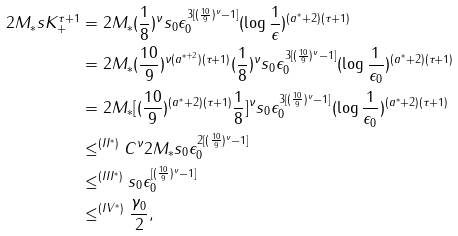Convert formula to latex. <formula><loc_0><loc_0><loc_500><loc_500>2 M _ { \ast } s K _ { + } ^ { \tau + 1 } & = 2 M _ { \ast } ( \frac { 1 } { 8 } ) ^ { \nu } s _ { 0 } \epsilon _ { 0 } ^ { 3 [ ( \frac { 1 0 } { 9 } ) ^ { \nu } - 1 ] } ( \log \frac { 1 } { \epsilon } ) ^ { ( a ^ { \ast } + 2 ) ( \tau + 1 ) } \\ & = 2 M _ { \ast } ( \frac { 1 0 } { 9 } ) ^ { \nu ( a ^ { \ast + 2 } ) ( \tau + 1 ) } ( \frac { 1 } { 8 } ) ^ { \nu } s _ { 0 } \epsilon _ { 0 } ^ { 3 [ ( \frac { 1 0 } { 9 } ) ^ { \nu } - 1 ] } ( \log \frac { 1 } { \epsilon _ { 0 } } ) ^ { ( a ^ { \ast } + 2 ) ( \tau + 1 ) } \\ & = 2 M _ { \ast } [ ( \frac { 1 0 } { 9 } ) ^ { ( a ^ { \ast } + 2 ) ( \tau + 1 ) } \frac { 1 } { 8 } ] ^ { \nu } s _ { 0 } \epsilon _ { 0 } ^ { 3 [ ( \frac { 1 0 } { 9 } ) ^ { \nu } - 1 ] } ( \log \frac { 1 } { \epsilon _ { 0 } } ) ^ { ( a ^ { \ast } + 2 ) ( \tau + 1 ) } \\ & \leq ^ { ( I I ^ { * } ) } C ^ { \nu } 2 M _ { \ast } s _ { 0 } \epsilon _ { 0 } ^ { 2 [ ( \frac { 1 0 } { 9 } ) ^ { \nu } - 1 ] } \\ & \leq ^ { ( I I I ^ { * } ) } s _ { 0 } \epsilon _ { 0 } ^ { [ ( \frac { 1 0 } { 9 } ) ^ { \nu } - 1 ] } \\ & \leq ^ { ( I V ^ { * } ) } \frac { \gamma _ { 0 } } { 2 } ,</formula> 